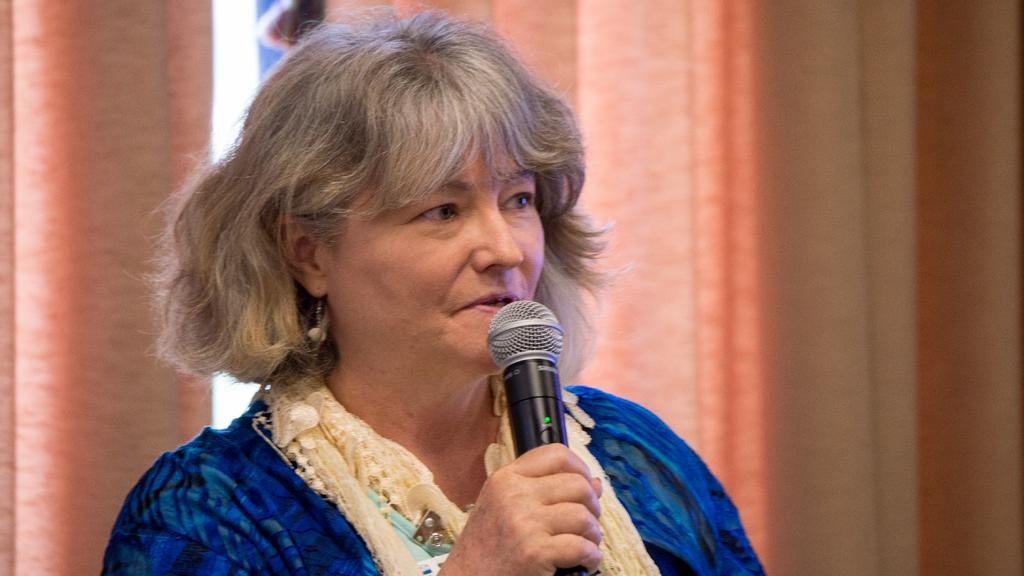Who is the main subject in the image? There is a woman in the image. What is the woman holding in her hand? The woman is holding a mic in her hand. What is the woman doing with the mic? The woman is talking. What can be seen in the background of the image? There are curtains in the background of the image. What type of produce is visible on the table in the image? There is no produce visible in the image; it features a woman holding a mic and talking. Can you tell me the total cost of the items purchased, as shown on the receipt in the image? There is no receipt present in the image. 